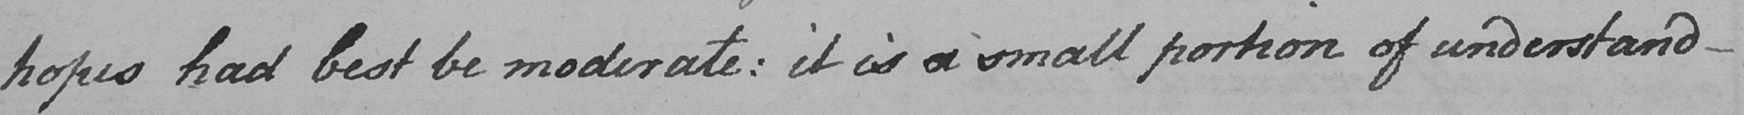What is written in this line of handwriting? hopes had best be moderate :  it is a small portion of understand- 